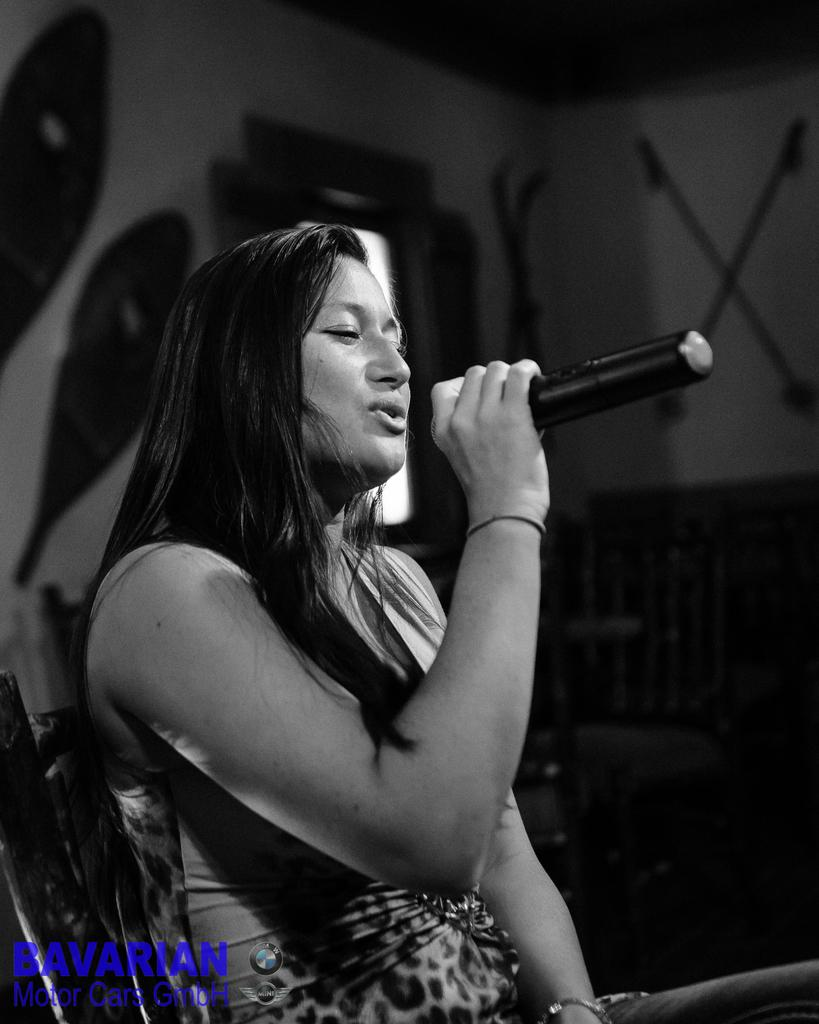Who is the main subject in the image? There is a woman in the image. What is the woman doing in the image? The woman is sitting and singing a song. What object is the woman holding in the image? The woman is holding a microphone. What can be seen in the background of the image? There is a wall and a door in the background of the image. What type of screw can be seen on the wall in the image? There is no screw visible on the wall in the image. Can you describe the ocean in the image? There is no ocean present in the image. 